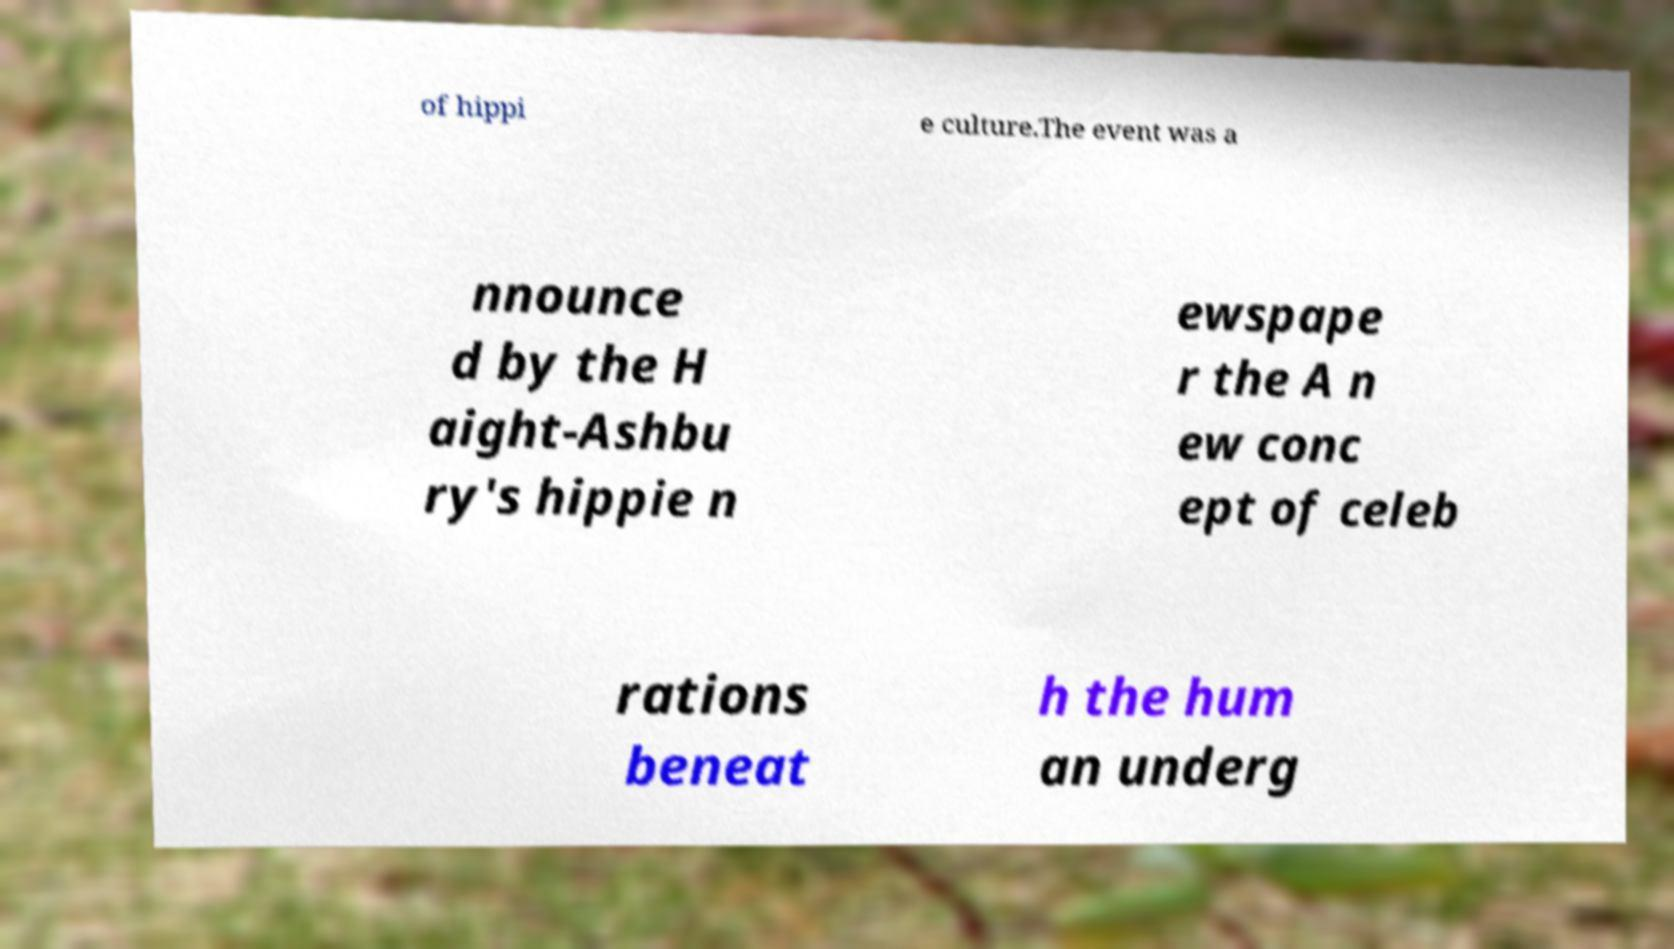I need the written content from this picture converted into text. Can you do that? of hippi e culture.The event was a nnounce d by the H aight-Ashbu ry's hippie n ewspape r the A n ew conc ept of celeb rations beneat h the hum an underg 